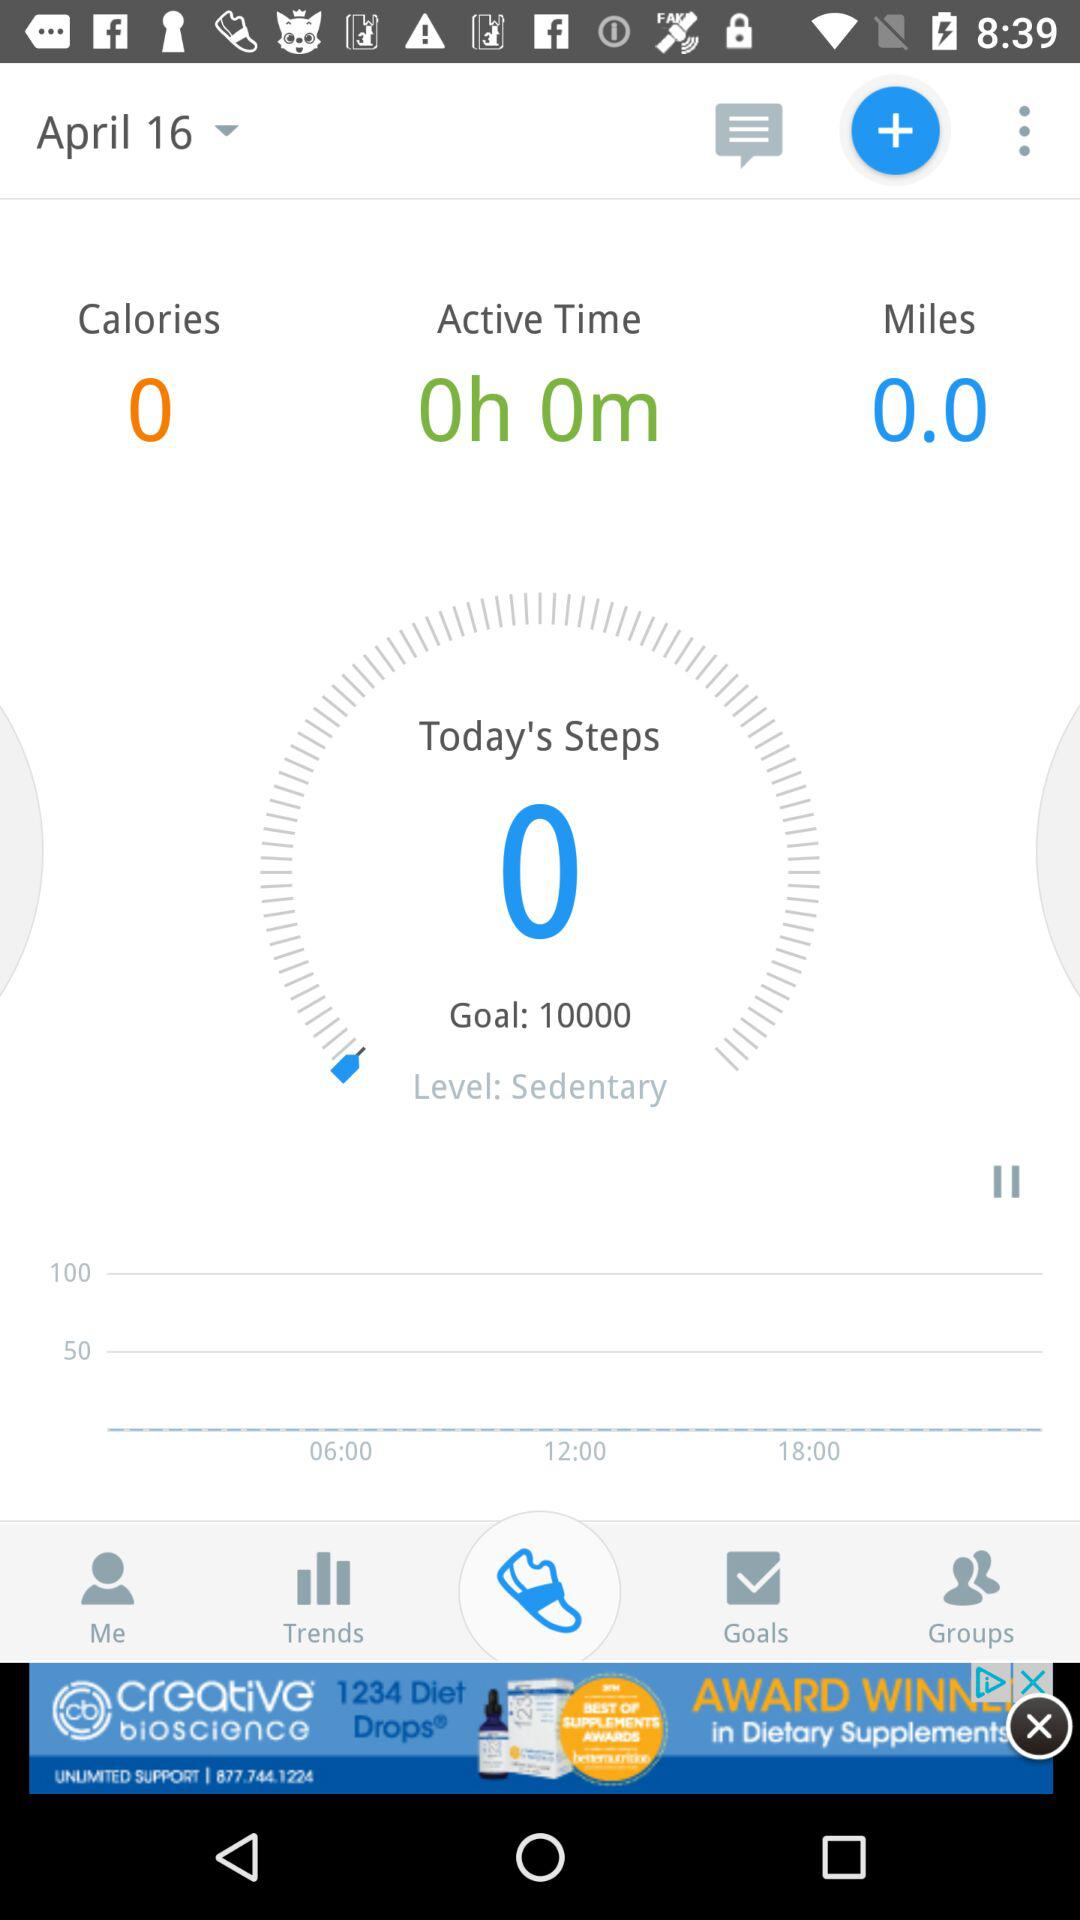How many miles are shown there? There are 0 miles. 